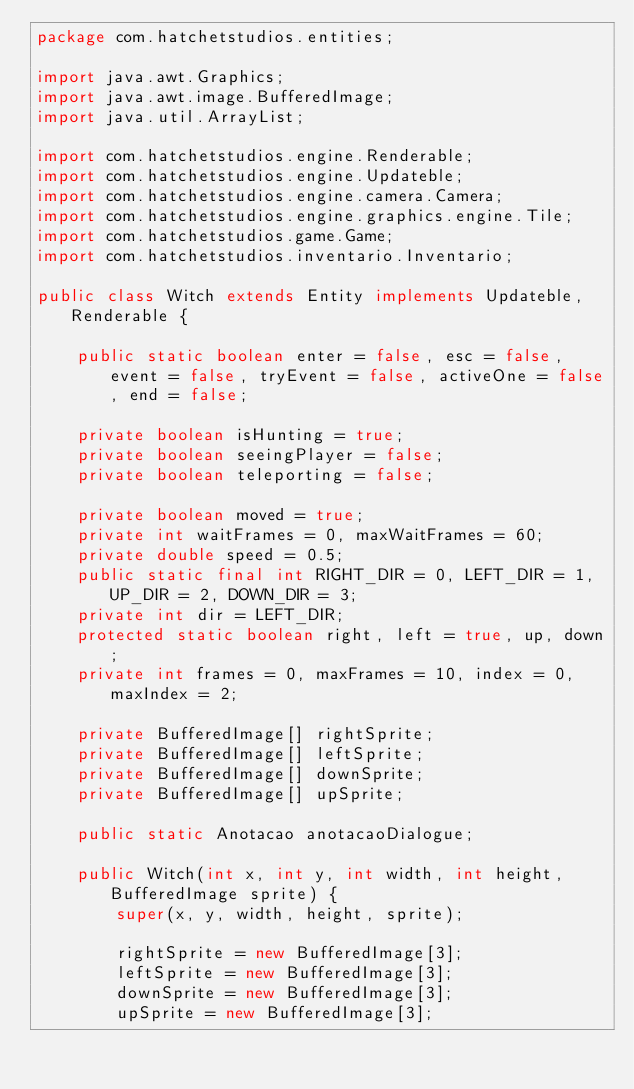Convert code to text. <code><loc_0><loc_0><loc_500><loc_500><_Java_>package com.hatchetstudios.entities;

import java.awt.Graphics;
import java.awt.image.BufferedImage;
import java.util.ArrayList;

import com.hatchetstudios.engine.Renderable;
import com.hatchetstudios.engine.Updateble;
import com.hatchetstudios.engine.camera.Camera;
import com.hatchetstudios.engine.graphics.engine.Tile;
import com.hatchetstudios.game.Game;
import com.hatchetstudios.inventario.Inventario;

public class Witch extends Entity implements Updateble, Renderable {

    public static boolean enter = false, esc = false, event = false, tryEvent = false, activeOne = false, end = false;

    private boolean isHunting = true;
    private boolean seeingPlayer = false;
    private boolean teleporting = false;

    private boolean moved = true;
    private int waitFrames = 0, maxWaitFrames = 60;
    private double speed = 0.5;
    public static final int RIGHT_DIR = 0, LEFT_DIR = 1, UP_DIR = 2, DOWN_DIR = 3;
    private int dir = LEFT_DIR;
    protected static boolean right, left = true, up, down;
    private int frames = 0, maxFrames = 10, index = 0, maxIndex = 2;

    private BufferedImage[] rightSprite;
    private BufferedImage[] leftSprite;
    private BufferedImage[] downSprite;
    private BufferedImage[] upSprite;

    public static Anotacao anotacaoDialogue;

    public Witch(int x, int y, int width, int height, BufferedImage sprite) {
        super(x, y, width, height, sprite);

        rightSprite = new BufferedImage[3];
        leftSprite = new BufferedImage[3];
        downSprite = new BufferedImage[3];
        upSprite = new BufferedImage[3];
</code> 